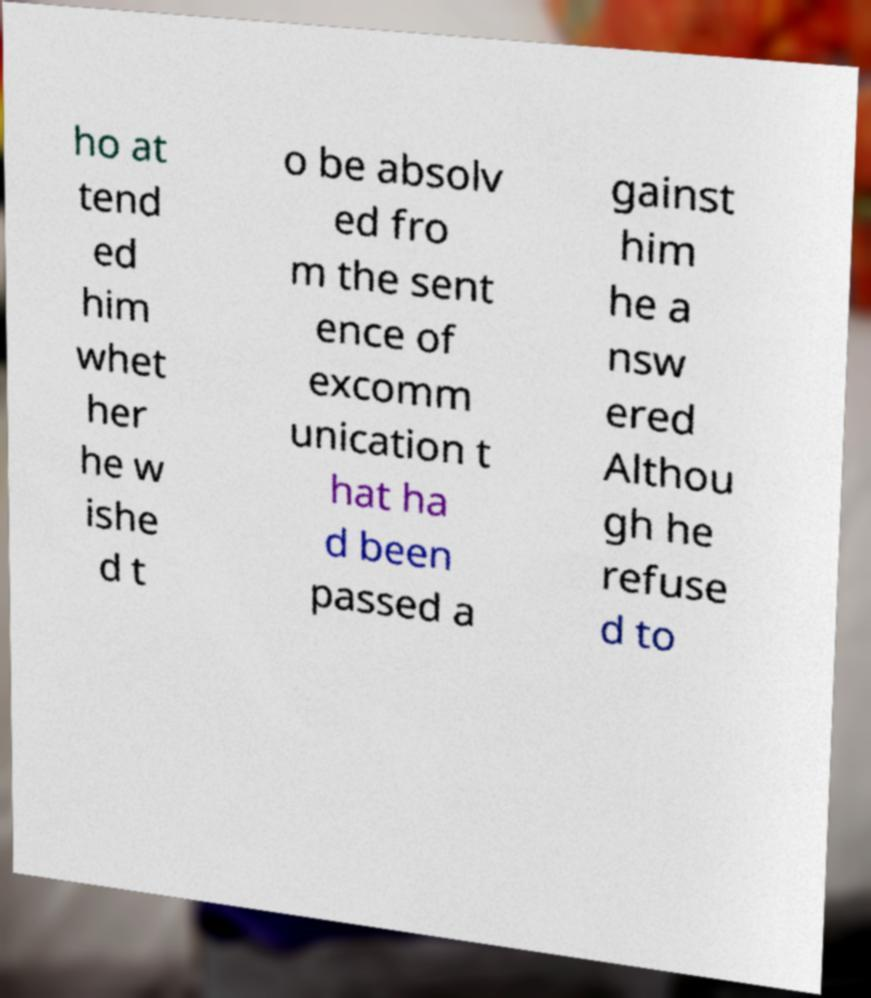Can you accurately transcribe the text from the provided image for me? ho at tend ed him whet her he w ishe d t o be absolv ed fro m the sent ence of excomm unication t hat ha d been passed a gainst him he a nsw ered Althou gh he refuse d to 